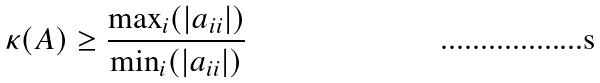Convert formula to latex. <formula><loc_0><loc_0><loc_500><loc_500>\kappa ( A ) \geq \frac { \max _ { i } ( | a _ { i i } | ) } { \min _ { i } ( | a _ { i i } | ) }</formula> 